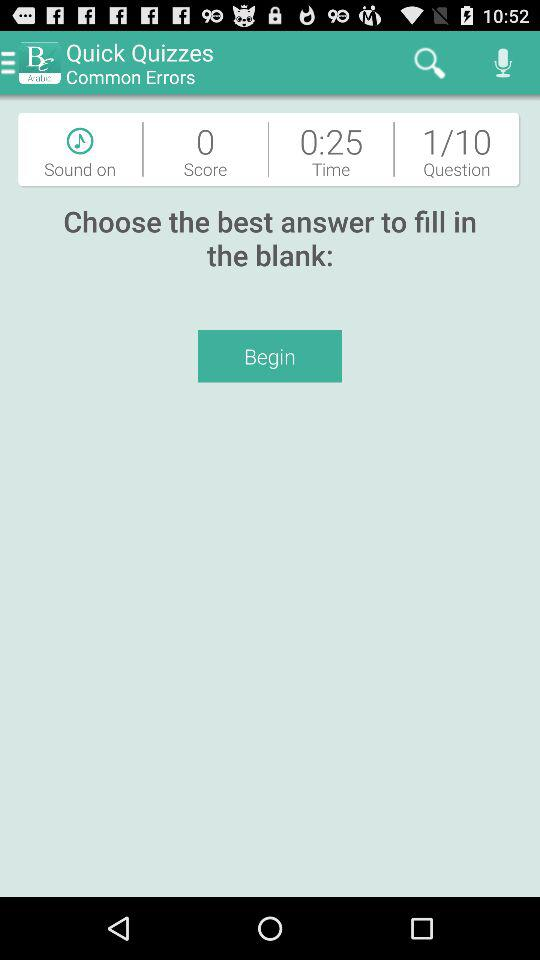How many questions are there in this? There are 10 questions. 